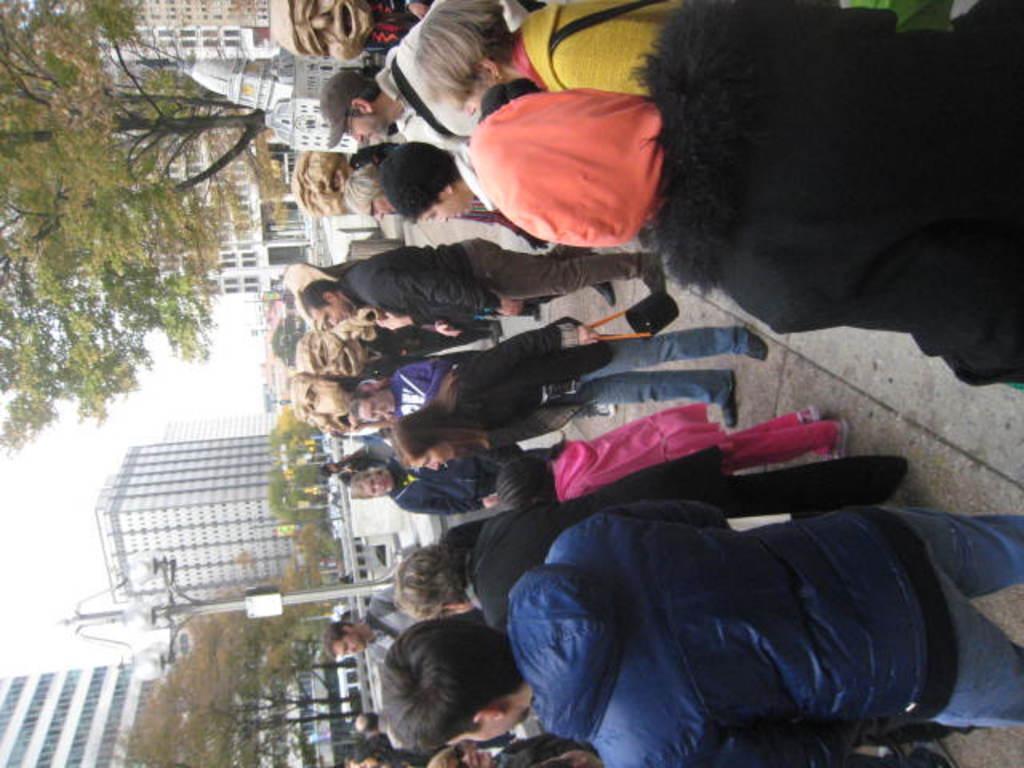Could you give a brief overview of what you see in this image? In the image there are many people standing in a street and in the back there are many buildings with trees in front of it, this is rotated image. 